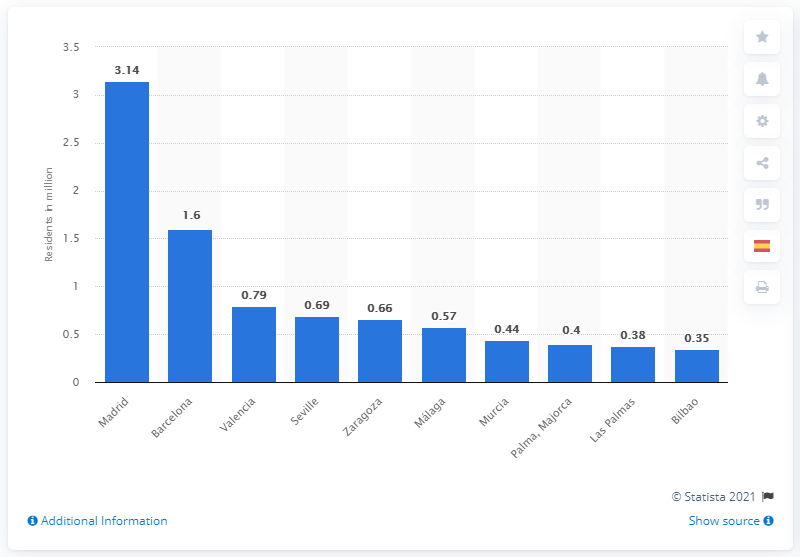Outline some significant characteristics in this image. In 2015, the population of Madrid was approximately 3.14 million people. 